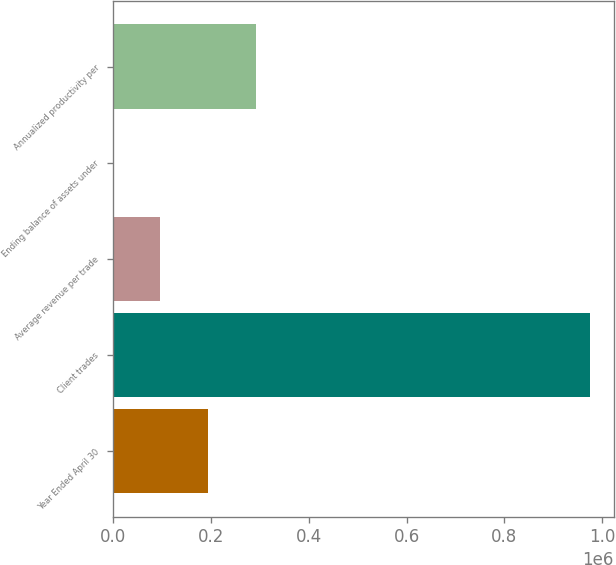Convert chart to OTSL. <chart><loc_0><loc_0><loc_500><loc_500><bar_chart><fcel>Year Ended April 30<fcel>Client trades<fcel>Average revenue per trade<fcel>Ending balance of assets under<fcel>Annualized productivity per<nl><fcel>194950<fcel>974625<fcel>97491.1<fcel>31.8<fcel>292410<nl></chart> 